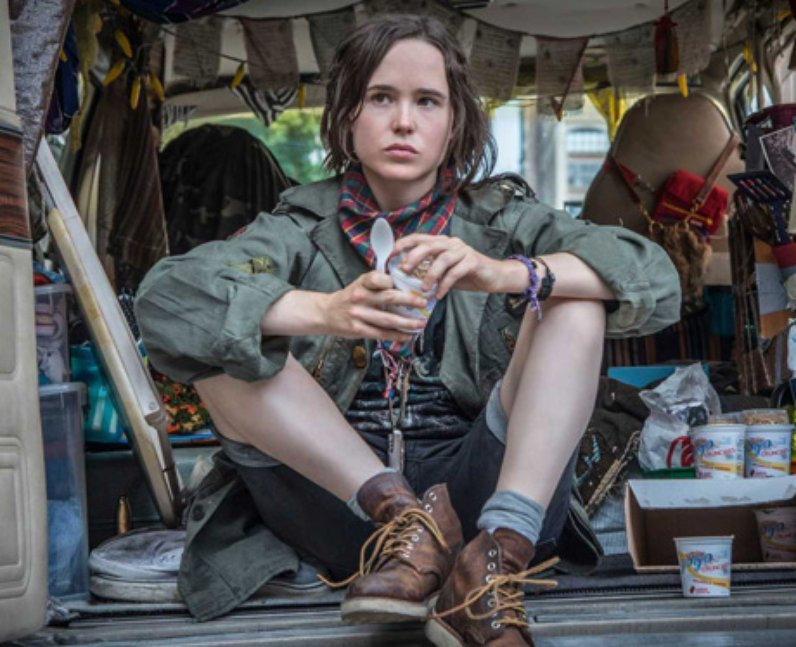Imagine a story based on this image. Be very creative. In a world where memories could be captured in physical objects, this van serves as a vessel of time and emotion. The person, known as the 'Memory Collector,' travels through towns and cities, gathering memories that people are willing to part with. Each object hanging from the ceiling or scattered on the floor holds a fragment of someone’s life story. As the Memory Collector sits, holding a cup that once meant a lot to its original owner, they ponder the countless lives they've touched and the stories they've safeguarded. The ribbon in their hand is said to be a legendary artifact capable of weaving all these memories into a timeline that could reveal the true essence of humanity's collective experience. 